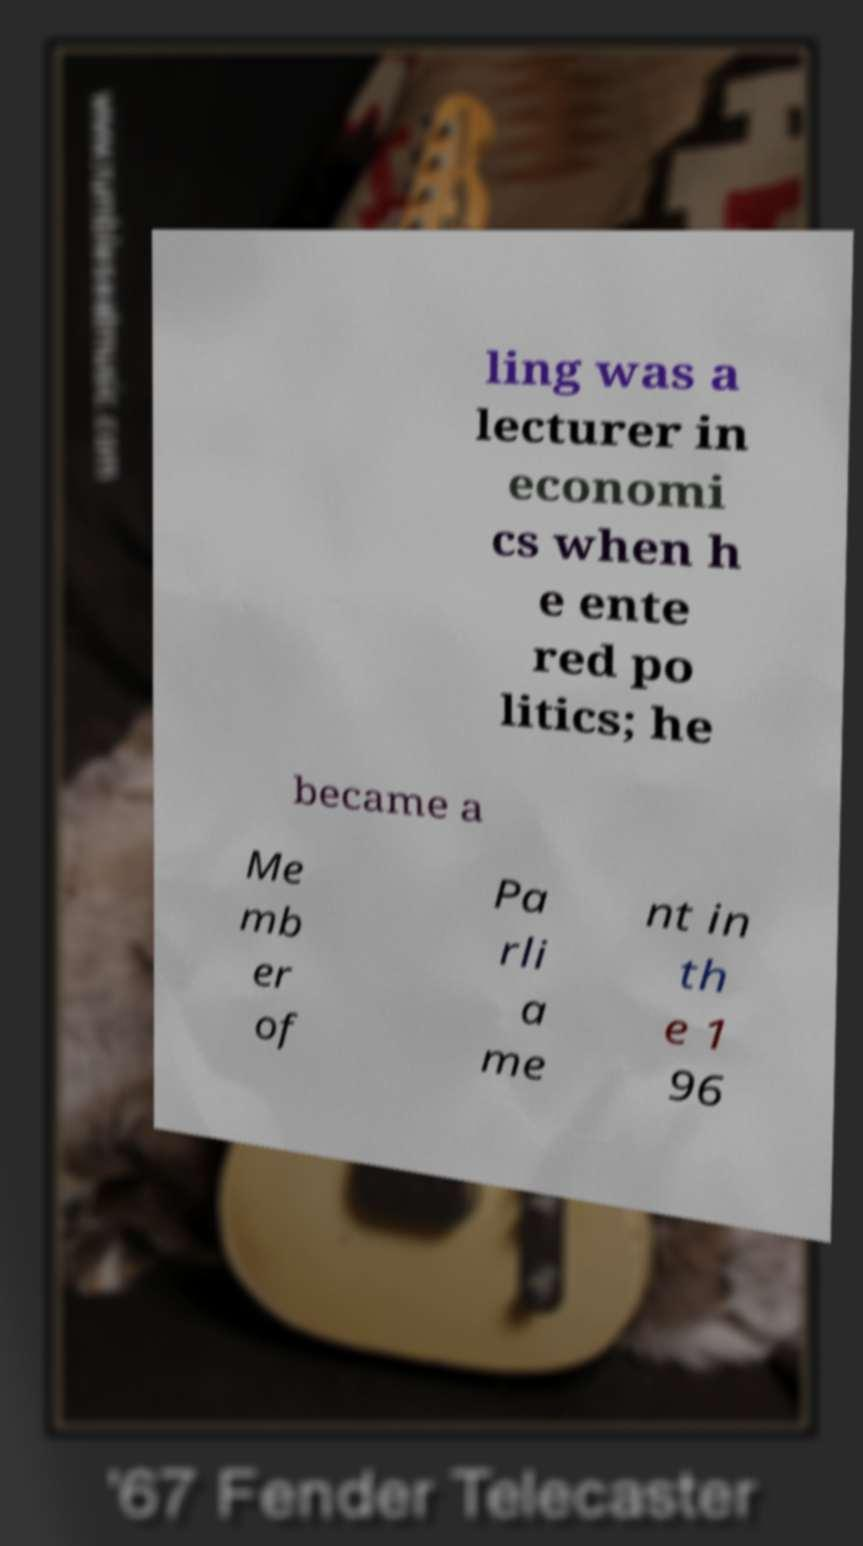Could you extract and type out the text from this image? ling was a lecturer in economi cs when h e ente red po litics; he became a Me mb er of Pa rli a me nt in th e 1 96 